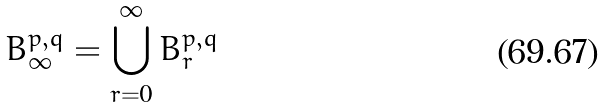<formula> <loc_0><loc_0><loc_500><loc_500>B _ { \infty } ^ { p , q } = \bigcup _ { r = 0 } ^ { \infty } B _ { r } ^ { p , q }</formula> 